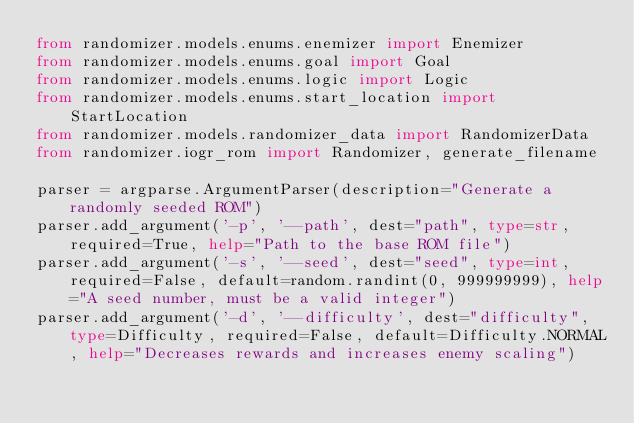<code> <loc_0><loc_0><loc_500><loc_500><_Python_>from randomizer.models.enums.enemizer import Enemizer
from randomizer.models.enums.goal import Goal
from randomizer.models.enums.logic import Logic
from randomizer.models.enums.start_location import StartLocation
from randomizer.models.randomizer_data import RandomizerData
from randomizer.iogr_rom import Randomizer, generate_filename

parser = argparse.ArgumentParser(description="Generate a randomly seeded ROM")
parser.add_argument('-p', '--path', dest="path", type=str, required=True, help="Path to the base ROM file")
parser.add_argument('-s', '--seed', dest="seed", type=int, required=False, default=random.randint(0, 999999999), help="A seed number, must be a valid integer")
parser.add_argument('-d', '--difficulty', dest="difficulty", type=Difficulty, required=False, default=Difficulty.NORMAL, help="Decreases rewards and increases enemy scaling")</code> 